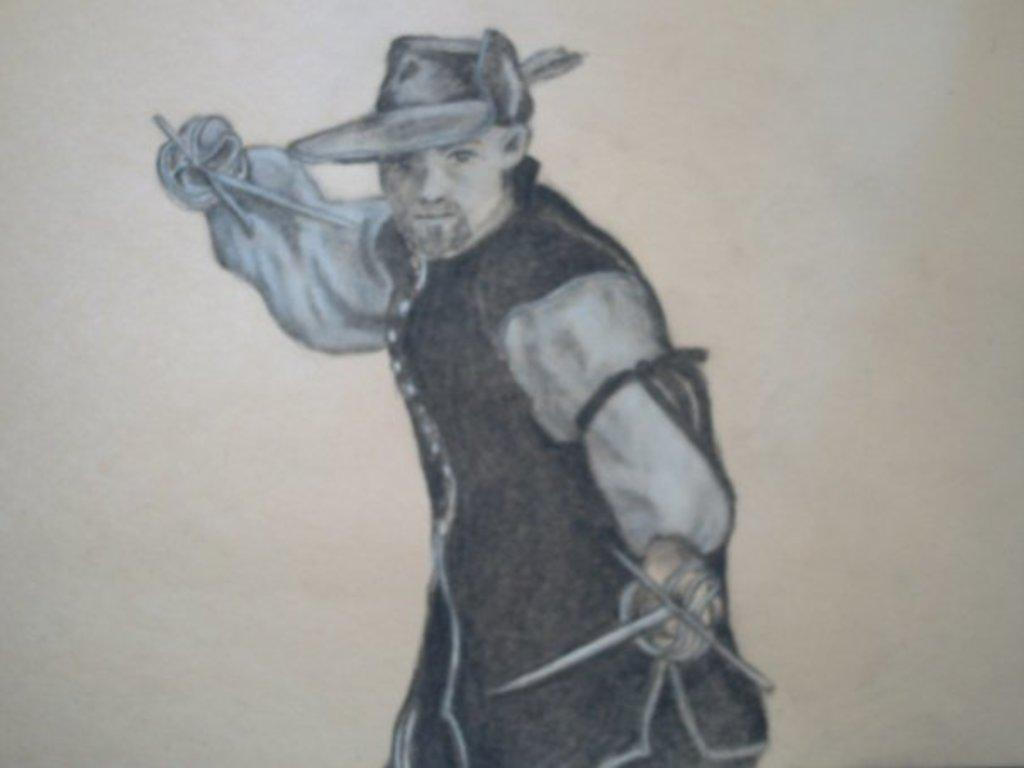What is the main subject of the image? There is a painting in the image. What does the painting depict? The painting depicts a person. What is the person in the painting doing? The person is holding objects in their hands. What is the color of the background in the painting? The background of the painting is white. How many sticks can be seen in the painting? There are no sticks present in the painting; the person is holding objects, but they are not sticks. 